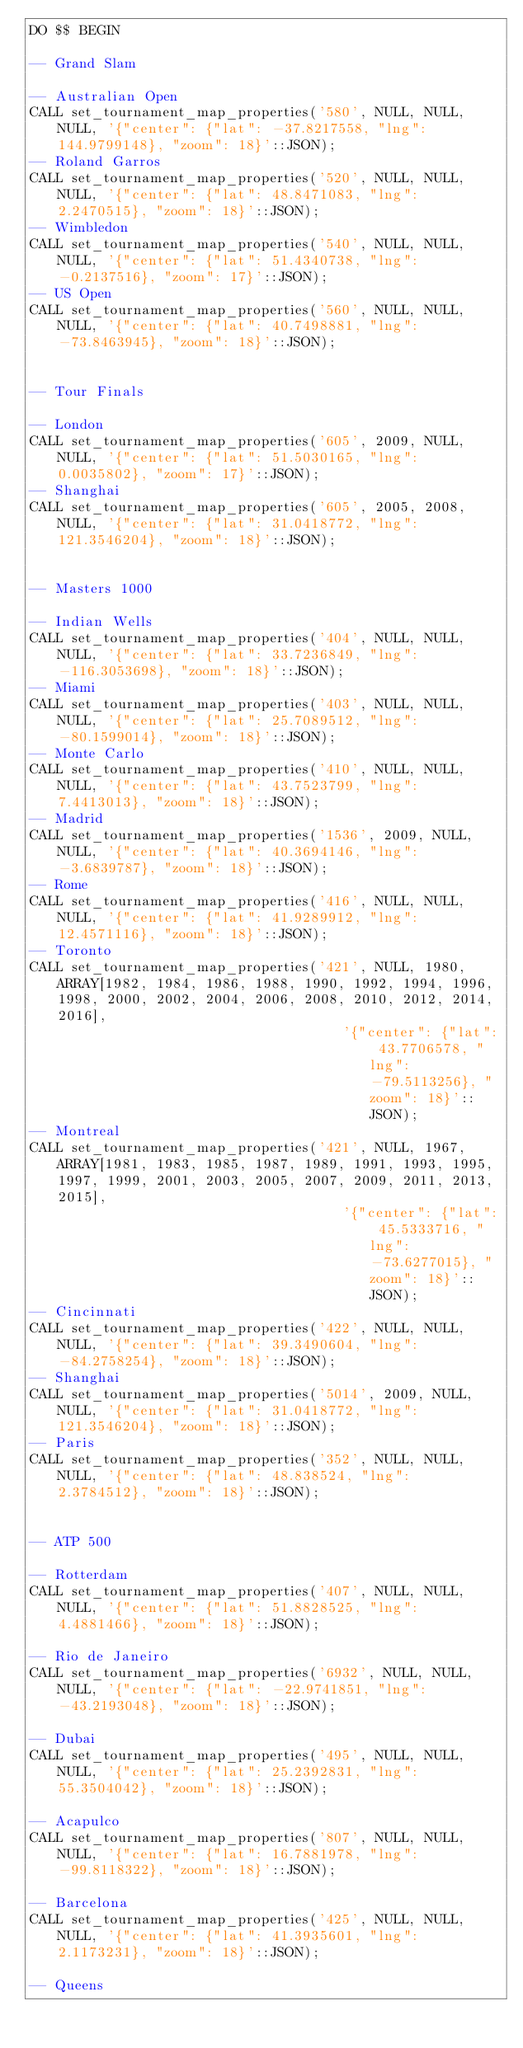Convert code to text. <code><loc_0><loc_0><loc_500><loc_500><_SQL_>DO $$ BEGIN

-- Grand Slam

-- Australian Open
CALL set_tournament_map_properties('580', NULL, NULL, NULL, '{"center": {"lat": -37.8217558, "lng": 144.9799148}, "zoom": 18}'::JSON);
-- Roland Garros
CALL set_tournament_map_properties('520', NULL, NULL, NULL, '{"center": {"lat": 48.8471083, "lng": 2.2470515}, "zoom": 18}'::JSON);
-- Wimbledon
CALL set_tournament_map_properties('540', NULL, NULL, NULL, '{"center": {"lat": 51.4340738, "lng": -0.2137516}, "zoom": 17}'::JSON);
-- US Open
CALL set_tournament_map_properties('560', NULL, NULL, NULL, '{"center": {"lat": 40.7498881, "lng": -73.8463945}, "zoom": 18}'::JSON);


-- Tour Finals

-- London
CALL set_tournament_map_properties('605', 2009, NULL, NULL, '{"center": {"lat": 51.5030165, "lng": 0.0035802}, "zoom": 17}'::JSON);
-- Shanghai
CALL set_tournament_map_properties('605', 2005, 2008, NULL, '{"center": {"lat": 31.0418772, "lng": 121.3546204}, "zoom": 18}'::JSON);


-- Masters 1000

-- Indian Wells
CALL set_tournament_map_properties('404', NULL, NULL, NULL, '{"center": {"lat": 33.7236849, "lng": -116.3053698}, "zoom": 18}'::JSON);
-- Miami
CALL set_tournament_map_properties('403', NULL, NULL, NULL, '{"center": {"lat": 25.7089512, "lng": -80.1599014}, "zoom": 18}'::JSON);
-- Monte Carlo
CALL set_tournament_map_properties('410', NULL, NULL, NULL, '{"center": {"lat": 43.7523799, "lng": 7.4413013}, "zoom": 18}'::JSON);
-- Madrid
CALL set_tournament_map_properties('1536', 2009, NULL, NULL, '{"center": {"lat": 40.3694146, "lng": -3.6839787}, "zoom": 18}'::JSON);
-- Rome
CALL set_tournament_map_properties('416', NULL, NULL, NULL, '{"center": {"lat": 41.9289912, "lng": 12.4571116}, "zoom": 18}'::JSON);
-- Toronto
CALL set_tournament_map_properties('421', NULL, 1980, ARRAY[1982, 1984, 1986, 1988, 1990, 1992, 1994, 1996, 1998, 2000, 2002, 2004, 2006, 2008, 2010, 2012, 2014, 2016],
                                      '{"center": {"lat": 43.7706578, "lng": -79.5113256}, "zoom": 18}'::JSON);
-- Montreal
CALL set_tournament_map_properties('421', NULL, 1967, ARRAY[1981, 1983, 1985, 1987, 1989, 1991, 1993, 1995, 1997, 1999, 2001, 2003, 2005, 2007, 2009, 2011, 2013, 2015],
                                      '{"center": {"lat": 45.5333716, "lng": -73.6277015}, "zoom": 18}'::JSON);
-- Cincinnati
CALL set_tournament_map_properties('422', NULL, NULL, NULL, '{"center": {"lat": 39.3490604, "lng": -84.2758254}, "zoom": 18}'::JSON);
-- Shanghai
CALL set_tournament_map_properties('5014', 2009, NULL, NULL, '{"center": {"lat": 31.0418772, "lng": 121.3546204}, "zoom": 18}'::JSON);
-- Paris
CALL set_tournament_map_properties('352', NULL, NULL, NULL, '{"center": {"lat": 48.838524, "lng": 2.3784512}, "zoom": 18}'::JSON);


-- ATP 500

-- Rotterdam
CALL set_tournament_map_properties('407', NULL, NULL, NULL, '{"center": {"lat": 51.8828525, "lng": 4.4881466}, "zoom": 18}'::JSON);

-- Rio de Janeiro
CALL set_tournament_map_properties('6932', NULL, NULL, NULL, '{"center": {"lat": -22.9741851, "lng": -43.2193048}, "zoom": 18}'::JSON);

-- Dubai
CALL set_tournament_map_properties('495', NULL, NULL, NULL, '{"center": {"lat": 25.2392831, "lng": 55.3504042}, "zoom": 18}'::JSON);

-- Acapulco
CALL set_tournament_map_properties('807', NULL, NULL, NULL, '{"center": {"lat": 16.7881978, "lng": -99.8118322}, "zoom": 18}'::JSON);

-- Barcelona
CALL set_tournament_map_properties('425', NULL, NULL, NULL, '{"center": {"lat": 41.3935601, "lng": 2.1173231}, "zoom": 18}'::JSON);

-- Queens</code> 